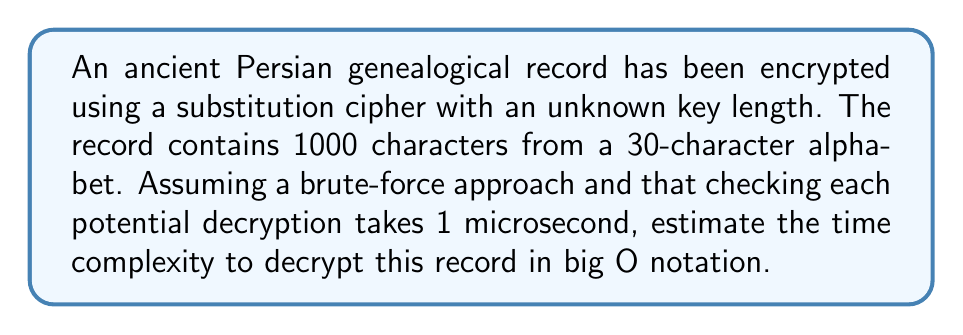Could you help me with this problem? Let's approach this step-by-step:

1) In a substitution cipher, each character in the plaintext is replaced by another character from the alphabet.

2) The number of possible keys for a substitution cipher with an alphabet of size $n$ is $n!$.

3) In this case, $n = 30$ (30-character alphabet).

4) The number of possible keys is thus $30!$.

5) For each key, we need to decrypt the entire message and check if it makes sense. This takes 1 microsecond per attempt.

6) Therefore, the total time $T$ in microseconds is:

   $T = 30! \times 1\mu s$

7) In big O notation, we ignore constant factors. The time complexity is thus $O(30!)$.

8) However, 30! is a constant (albeit a very large one). In big O notation, we typically express complexity in terms of the input size.

9) The input size here is the length of the message, which is 1000 characters. Let's call this $n$.

10) The time to check each decryption attempt is proportional to $n$.

11) Therefore, the overall time complexity is $O(n)$, as the number of keys to check (30!) is constant with respect to $n$.
Answer: $O(n)$ 